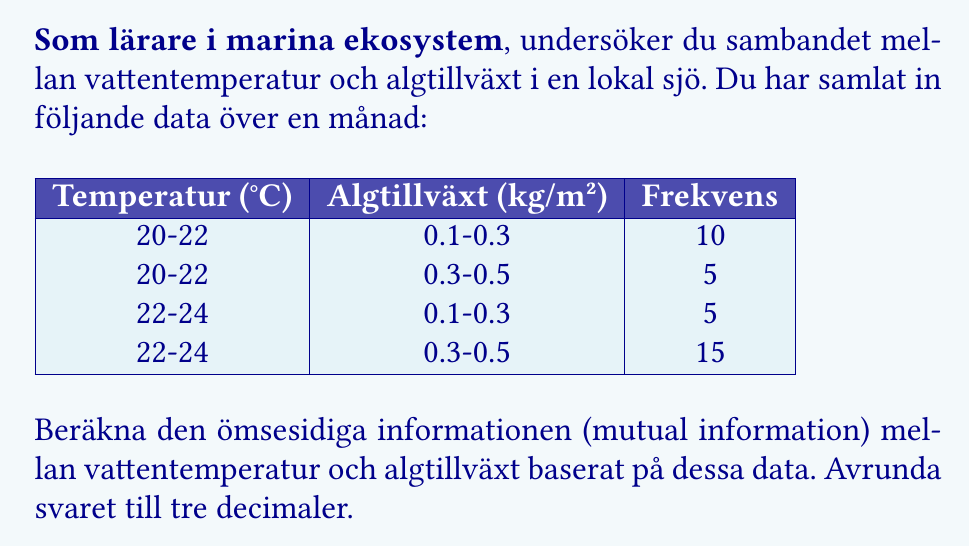Give your solution to this math problem. För att beräkna den ömsesidiga informationen behöver vi följa dessa steg:

1) Beräkna marginalfördelningarna:
   P(T₁) = P(20-22°C) = (10+5)/35 = 15/35
   P(T₂) = P(22-24°C) = (5+15)/35 = 20/35
   P(A₁) = P(0.1-0.3 kg/m²) = (10+5)/35 = 15/35
   P(A₂) = P(0.3-0.5 kg/m²) = (5+15)/35 = 20/35

2) Beräkna de gemensamma sannolikheterna:
   P(T₁,A₁) = 10/35
   P(T₁,A₂) = 5/35
   P(T₂,A₁) = 5/35
   P(T₂,A₂) = 15/35

3) Beräkna den ömsesidiga informationen med formeln:
   $$I(T;A) = \sum_{t,a} P(t,a) \log_2 \frac{P(t,a)}{P(t)P(a)}$$

   För varje kombination:
   $$\frac{10}{35} \log_2 \frac{10/35}{(15/35)(15/35)} + \frac{5}{35} \log_2 \frac{5/35}{(15/35)(20/35)} + \frac{5}{35} \log_2 \frac{5/35}{(20/35)(15/35)} + \frac{15}{35} \log_2 \frac{15/35}{(20/35)(20/35)}$$

4) Beräkna varje term:
   $\frac{10}{35} \log_2 \frac{10 \cdot 35}{15 \cdot 15} = 0.0365$
   $\frac{5}{35} \log_2 \frac{5 \cdot 35}{15 \cdot 20} = -0.0436$
   $\frac{5}{35} \log_2 \frac{5 \cdot 35}{20 \cdot 15} = -0.0436$
   $\frac{15}{35} \log_2 \frac{15 \cdot 35}{20 \cdot 20} = 0.0802$

5) Summera termerna:
   $I(T;A) = 0.0365 - 0.0436 - 0.0436 + 0.0802 = 0.0295$ bits

6) Avrunda till tre decimaler: 0.030 bits
Answer: 0.030 bits 